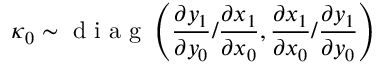<formula> <loc_0><loc_0><loc_500><loc_500>\boldsymbol \kappa _ { 0 } \sim d i a g \left ( \frac { \partial y _ { 1 } } { \partial y _ { 0 } } / \frac { \partial x _ { 1 } } { \partial x _ { 0 } } , \frac { \partial x _ { 1 } } { \partial x _ { 0 } } / \frac { \partial y _ { 1 } } { \partial y _ { 0 } } \right )</formula> 